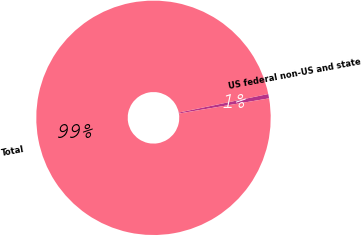Convert chart to OTSL. <chart><loc_0><loc_0><loc_500><loc_500><pie_chart><fcel>US federal non-US and state<fcel>Total<nl><fcel>0.6%<fcel>99.4%<nl></chart> 